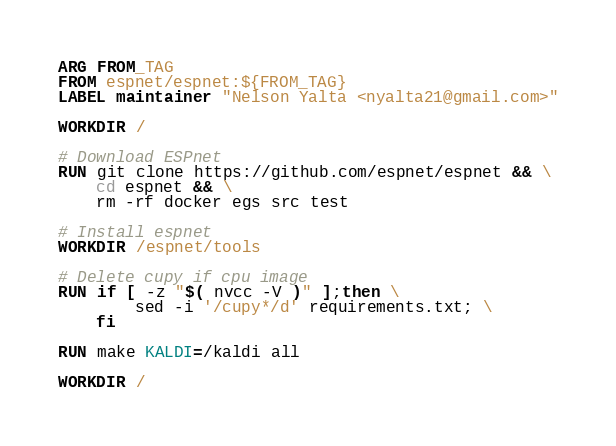Convert code to text. <code><loc_0><loc_0><loc_500><loc_500><_Dockerfile_>ARG FROM_TAG
FROM espnet/espnet:${FROM_TAG}
LABEL maintainer "Nelson Yalta <nyalta21@gmail.com>"

WORKDIR /

# Download ESPnet
RUN git clone https://github.com/espnet/espnet && \
    cd espnet && \
    rm -rf docker egs src test

# Install espnet
WORKDIR /espnet/tools

# Delete cupy if cpu image
RUN if [ -z "$( nvcc -V )" ];then \
        sed -i '/cupy*/d' requirements.txt; \
    fi 

RUN make KALDI=/kaldi all 

WORKDIR /</code> 